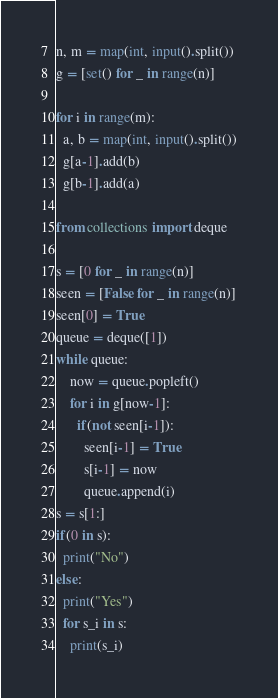Convert code to text. <code><loc_0><loc_0><loc_500><loc_500><_Python_>n, m = map(int, input().split())
g = [set() for _ in range(n)]

for i in range(m):
  a, b = map(int, input().split())
  g[a-1].add(b)
  g[b-1].add(a)

from collections import deque

s = [0 for _ in range(n)]
seen = [False for _ in range(n)]
seen[0] = True
queue = deque([1])
while queue:
    now = queue.popleft()
    for i in g[now-1]:
      if(not seen[i-1]):
        seen[i-1] = True
        s[i-1] = now
        queue.append(i)
s = s[1:]
if(0 in s):
  print("No")
else:
  print("Yes")
  for s_i in s:
    print(s_i)</code> 